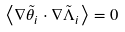<formula> <loc_0><loc_0><loc_500><loc_500>\left < \nabla { \tilde { \theta } } _ { i } \cdot \nabla { \tilde { \Lambda } } _ { i } \right > = 0</formula> 